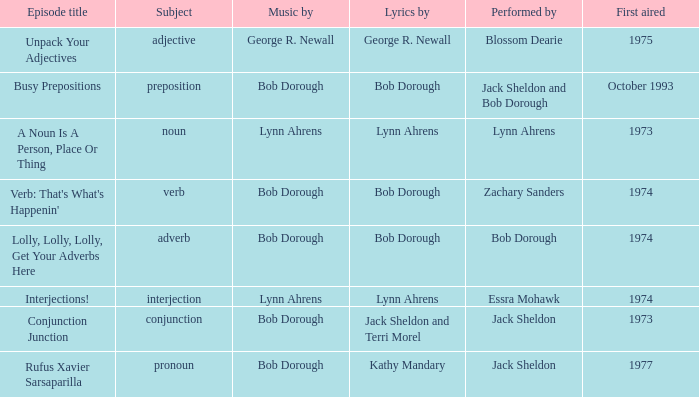Parse the table in full. {'header': ['Episode title', 'Subject', 'Music by', 'Lyrics by', 'Performed by', 'First aired'], 'rows': [['Unpack Your Adjectives', 'adjective', 'George R. Newall', 'George R. Newall', 'Blossom Dearie', '1975'], ['Busy Prepositions', 'preposition', 'Bob Dorough', 'Bob Dorough', 'Jack Sheldon and Bob Dorough', 'October 1993'], ['A Noun Is A Person, Place Or Thing', 'noun', 'Lynn Ahrens', 'Lynn Ahrens', 'Lynn Ahrens', '1973'], ["Verb: That's What's Happenin'", 'verb', 'Bob Dorough', 'Bob Dorough', 'Zachary Sanders', '1974'], ['Lolly, Lolly, Lolly, Get Your Adverbs Here', 'adverb', 'Bob Dorough', 'Bob Dorough', 'Bob Dorough', '1974'], ['Interjections!', 'interjection', 'Lynn Ahrens', 'Lynn Ahrens', 'Essra Mohawk', '1974'], ['Conjunction Junction', 'conjunction', 'Bob Dorough', 'Jack Sheldon and Terri Morel', 'Jack Sheldon', '1973'], ['Rufus Xavier Sarsaparilla', 'pronoun', 'Bob Dorough', 'Kathy Mandary', 'Jack Sheldon', '1977']]} When zachary sanders is the performer how many people is the music by? 1.0. 